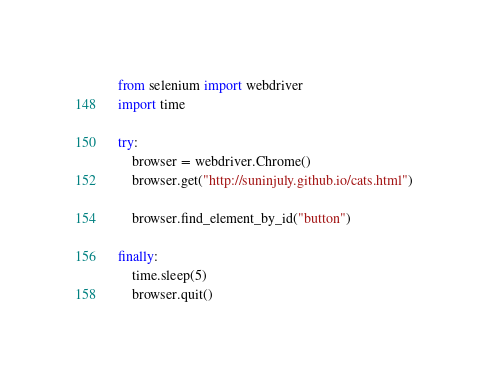Convert code to text. <code><loc_0><loc_0><loc_500><loc_500><_Python_>from selenium import webdriver
import time

try:
    browser = webdriver.Chrome()
    browser.get("http://suninjuly.github.io/cats.html")

    browser.find_element_by_id("button")

finally:
    time.sleep(5)
    browser.quit()
</code> 